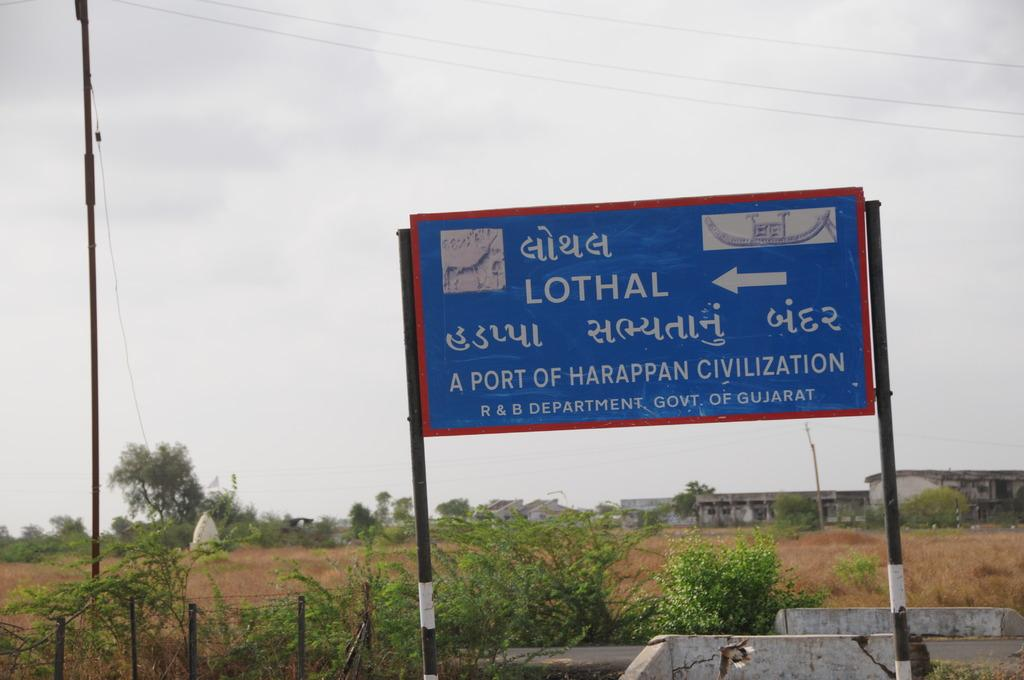<image>
Write a terse but informative summary of the picture. A blue billboard covered in many languages, and an arrow pointing to a town called Lothal. 